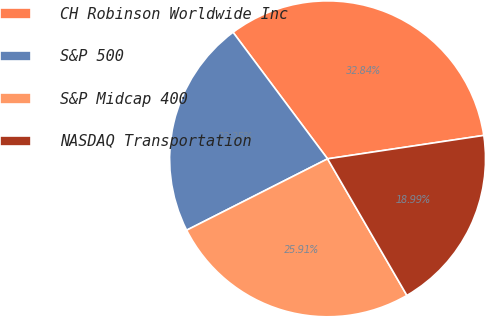Convert chart. <chart><loc_0><loc_0><loc_500><loc_500><pie_chart><fcel>CH Robinson Worldwide Inc<fcel>S&P 500<fcel>S&P Midcap 400<fcel>NASDAQ Transportation<nl><fcel>32.84%<fcel>22.25%<fcel>25.91%<fcel>18.99%<nl></chart> 